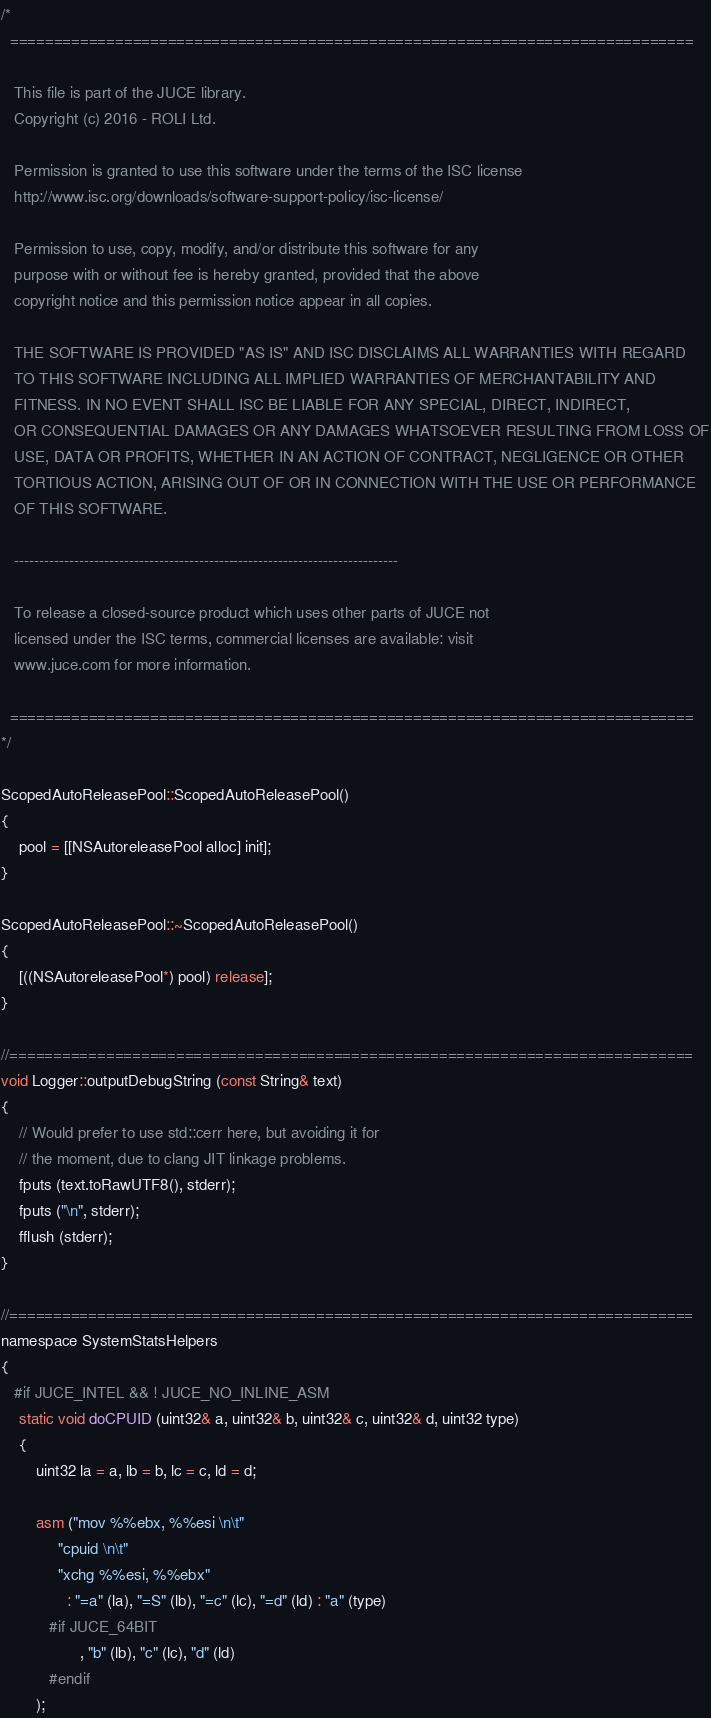Convert code to text. <code><loc_0><loc_0><loc_500><loc_500><_ObjectiveC_>/*
  ==============================================================================

   This file is part of the JUCE library.
   Copyright (c) 2016 - ROLI Ltd.

   Permission is granted to use this software under the terms of the ISC license
   http://www.isc.org/downloads/software-support-policy/isc-license/

   Permission to use, copy, modify, and/or distribute this software for any
   purpose with or without fee is hereby granted, provided that the above
   copyright notice and this permission notice appear in all copies.

   THE SOFTWARE IS PROVIDED "AS IS" AND ISC DISCLAIMS ALL WARRANTIES WITH REGARD
   TO THIS SOFTWARE INCLUDING ALL IMPLIED WARRANTIES OF MERCHANTABILITY AND
   FITNESS. IN NO EVENT SHALL ISC BE LIABLE FOR ANY SPECIAL, DIRECT, INDIRECT,
   OR CONSEQUENTIAL DAMAGES OR ANY DAMAGES WHATSOEVER RESULTING FROM LOSS OF
   USE, DATA OR PROFITS, WHETHER IN AN ACTION OF CONTRACT, NEGLIGENCE OR OTHER
   TORTIOUS ACTION, ARISING OUT OF OR IN CONNECTION WITH THE USE OR PERFORMANCE
   OF THIS SOFTWARE.

   -----------------------------------------------------------------------------

   To release a closed-source product which uses other parts of JUCE not
   licensed under the ISC terms, commercial licenses are available: visit
   www.juce.com for more information.

  ==============================================================================
*/

ScopedAutoReleasePool::ScopedAutoReleasePool()
{
    pool = [[NSAutoreleasePool alloc] init];
}

ScopedAutoReleasePool::~ScopedAutoReleasePool()
{
    [((NSAutoreleasePool*) pool) release];
}

//==============================================================================
void Logger::outputDebugString (const String& text)
{
    // Would prefer to use std::cerr here, but avoiding it for
    // the moment, due to clang JIT linkage problems.
    fputs (text.toRawUTF8(), stderr);
    fputs ("\n", stderr);
    fflush (stderr);
}

//==============================================================================
namespace SystemStatsHelpers
{
   #if JUCE_INTEL && ! JUCE_NO_INLINE_ASM
    static void doCPUID (uint32& a, uint32& b, uint32& c, uint32& d, uint32 type)
    {
        uint32 la = a, lb = b, lc = c, ld = d;

        asm ("mov %%ebx, %%esi \n\t"
             "cpuid \n\t"
             "xchg %%esi, %%ebx"
               : "=a" (la), "=S" (lb), "=c" (lc), "=d" (ld) : "a" (type)
           #if JUCE_64BIT
                  , "b" (lb), "c" (lc), "d" (ld)
           #endif
        );
</code> 